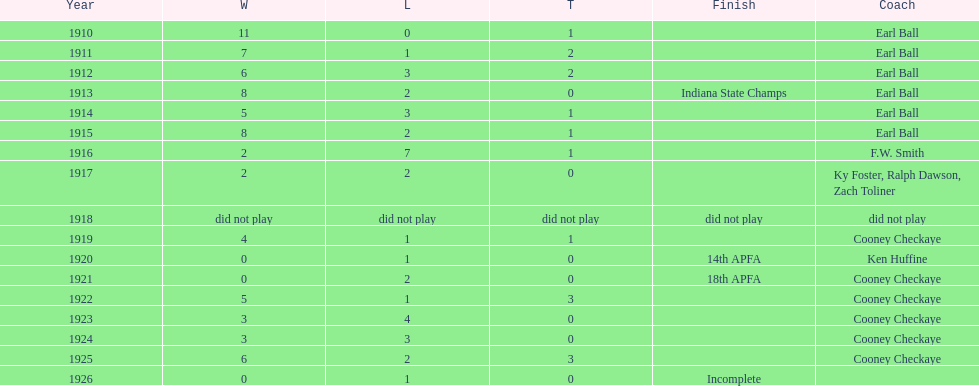In what year did the muncie flyers have an undefeated record? 1910. 